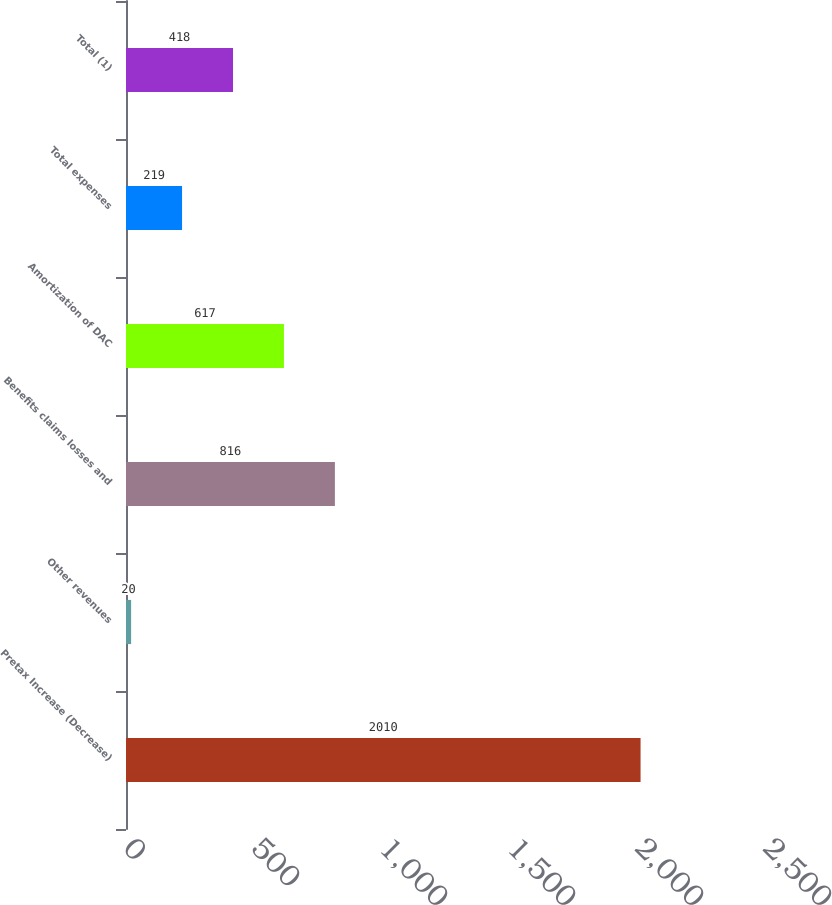<chart> <loc_0><loc_0><loc_500><loc_500><bar_chart><fcel>Pretax Increase (Decrease)<fcel>Other revenues<fcel>Benefits claims losses and<fcel>Amortization of DAC<fcel>Total expenses<fcel>Total (1)<nl><fcel>2010<fcel>20<fcel>816<fcel>617<fcel>219<fcel>418<nl></chart> 